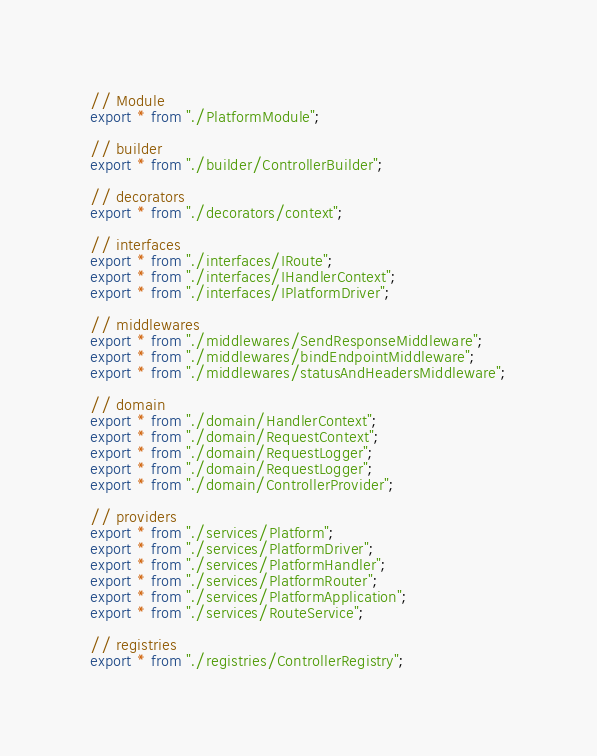<code> <loc_0><loc_0><loc_500><loc_500><_TypeScript_>// Module
export * from "./PlatformModule";

// builder
export * from "./builder/ControllerBuilder";

// decorators
export * from "./decorators/context";

// interfaces
export * from "./interfaces/IRoute";
export * from "./interfaces/IHandlerContext";
export * from "./interfaces/IPlatformDriver";

// middlewares
export * from "./middlewares/SendResponseMiddleware";
export * from "./middlewares/bindEndpointMiddleware";
export * from "./middlewares/statusAndHeadersMiddleware";

// domain
export * from "./domain/HandlerContext";
export * from "./domain/RequestContext";
export * from "./domain/RequestLogger";
export * from "./domain/RequestLogger";
export * from "./domain/ControllerProvider";

// providers
export * from "./services/Platform";
export * from "./services/PlatformDriver";
export * from "./services/PlatformHandler";
export * from "./services/PlatformRouter";
export * from "./services/PlatformApplication";
export * from "./services/RouteService";

// registries
export * from "./registries/ControllerRegistry";
</code> 